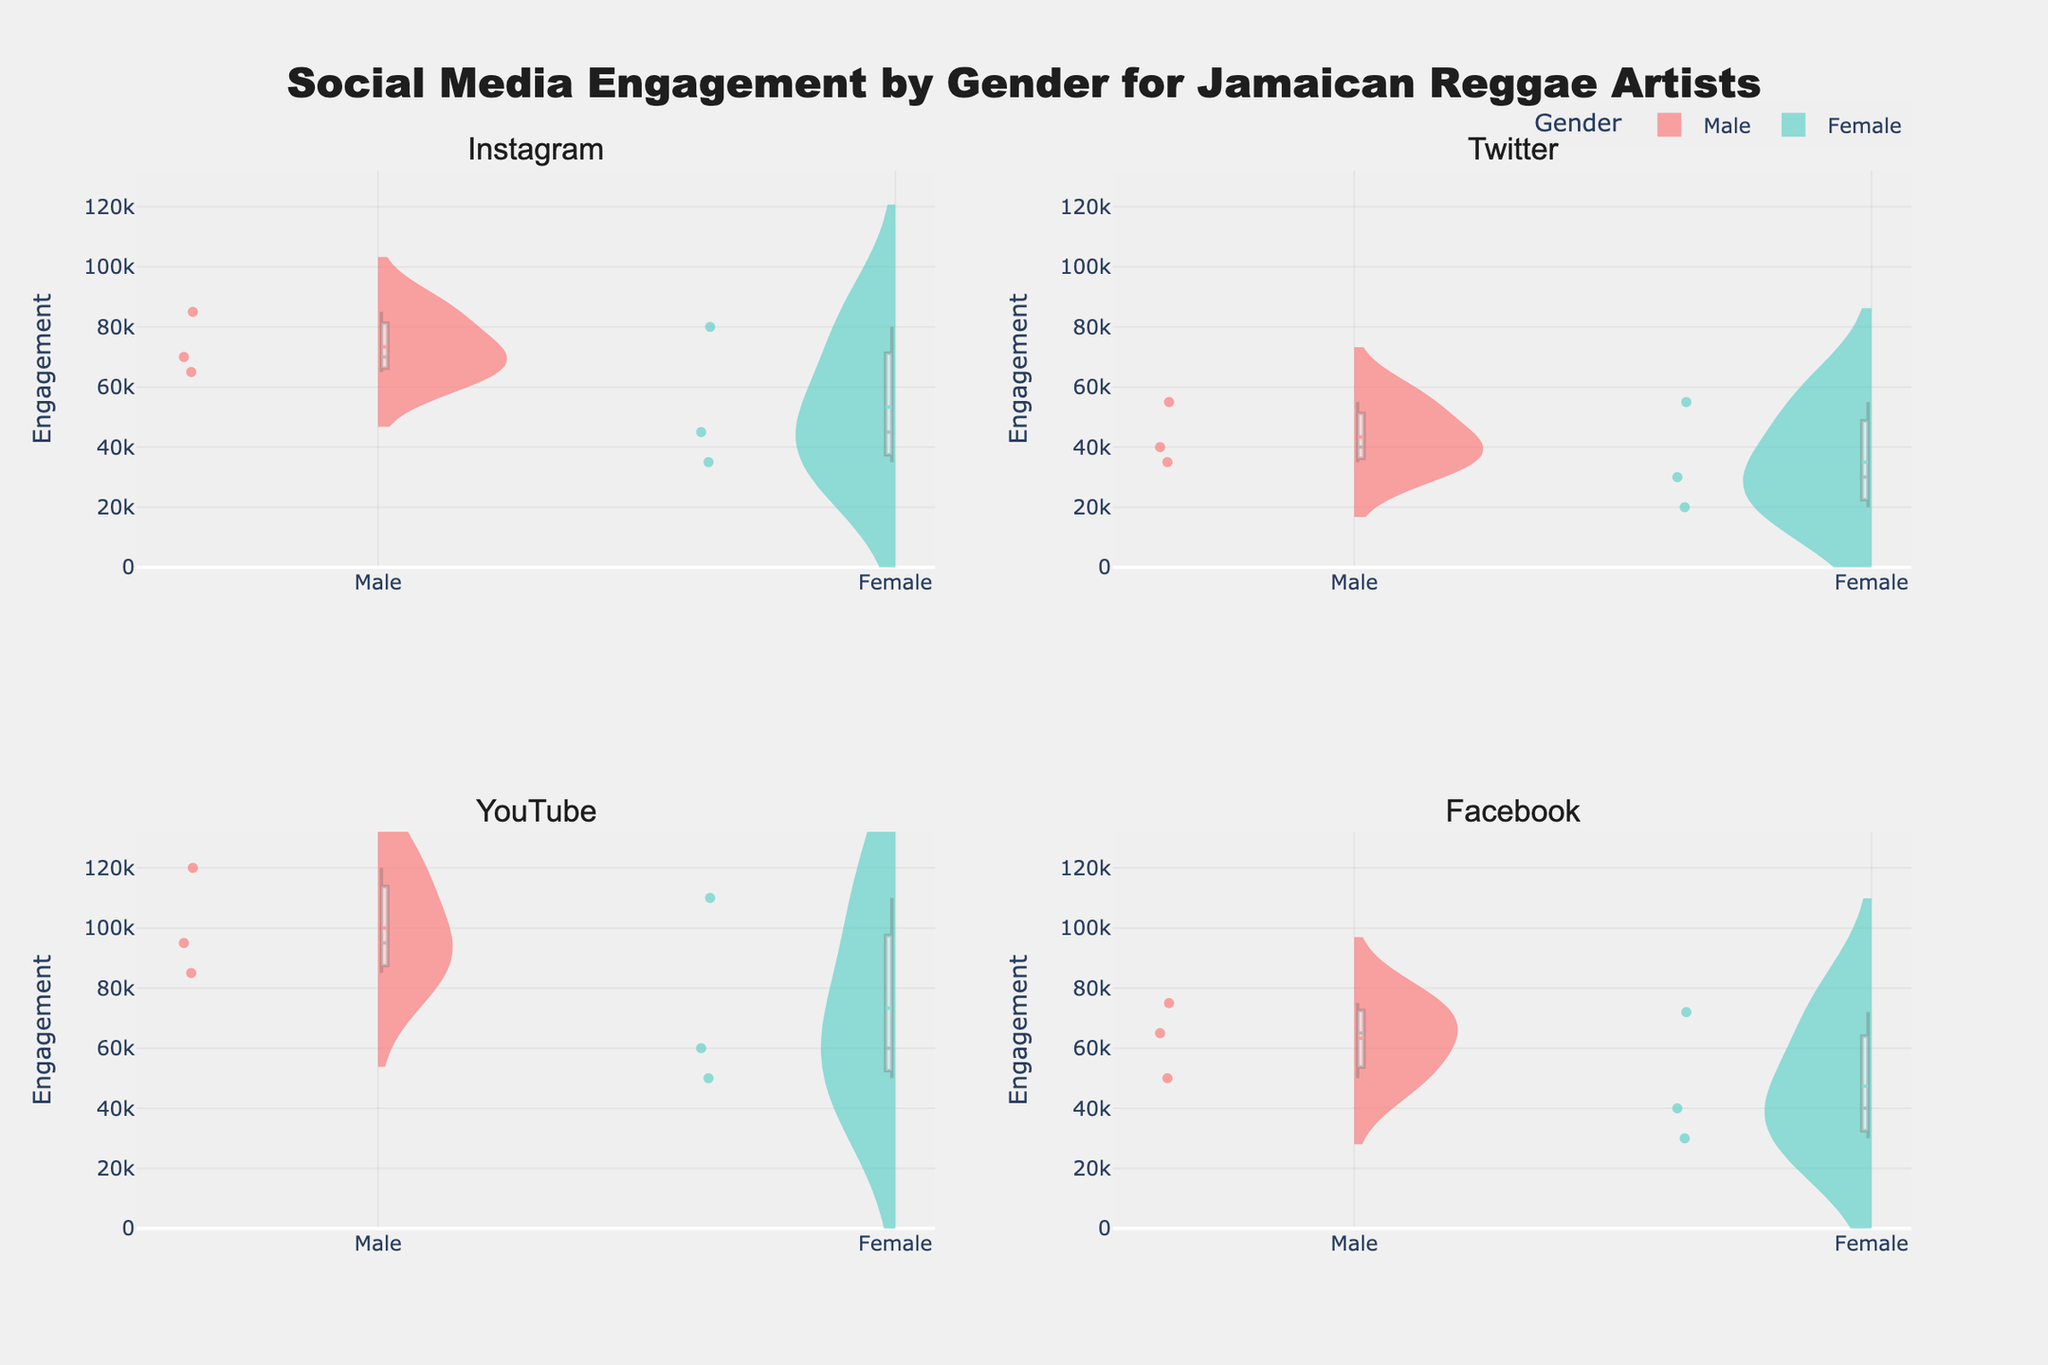What is the title of the figure? The title is usually centered at the top of the figure in a larger and bold font to make it stand out. Here, it says "Social Media Engagement by Gender for Jamaican Reggae Artists".
Answer: Social Media Engagement by Gender for Jamaican Reggae Artists Which social media platform shows the highest engagement for female artists? To identify the platform with the highest engagement for female artists, observe the highest violin plot peak for the 'Female' gender across all subplots. YouTube has the highest peak for females.
Answer: YouTube What is the median engagement for male artists on Instagram? The median value is shown as a horizontal line within the violin plot. Look at the Instagram subplot, and identify the median line for male artists.
Answer: 70000 Which gender has a greater variability in engagement on Twitter? Variability in a violin plot can be assessed by the spread or width of the plot. For Twitter, observe which gender's plot is wider. The width indicates variability.
Answer: Male How does the engagement on Facebook for Marcia Griffiths compare to Koffee? To compare, look at the data points for Marcia Griffiths and Koffee in the Facebook violin plot. Marcia's engagement is 40000, and Koffee's is 72000. Hence, Koffee has higher engagement.
Answer: Koffee's engagement is higher What is the engagement range for male artists on YouTube? The range can be found by looking at the highest and lowest points of the male violin plot in the YouTube subplot. The lowest is 85000, and the highest is 120000.
Answer: 85000 to 120000 Which platform shows the smallest difference in engagement between genders? To determine this, compare the overlaps or the closeness of the male and female violin plots' peaks and widths. Facebook seems to show the smallest gap visually.
Answer: Facebook What is the mean engagement for female artists on Instagram? Each violin plot includes a mean line, often denoted differently. Look at the Instagram subplot's female section for the line representing the mean.
Answer: 53333 (approx) On which platform do male artists have the highest engagement? Look at the peaks of the male violin plots across all platforms. YouTube has the highest peak for male artists, around 120000.
Answer: YouTube 